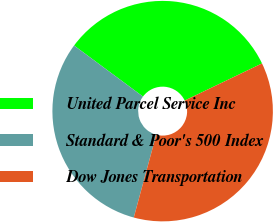Convert chart. <chart><loc_0><loc_0><loc_500><loc_500><pie_chart><fcel>United Parcel Service Inc<fcel>Standard & Poor's 500 Index<fcel>Dow Jones Transportation<nl><fcel>32.73%<fcel>30.93%<fcel>36.34%<nl></chart> 